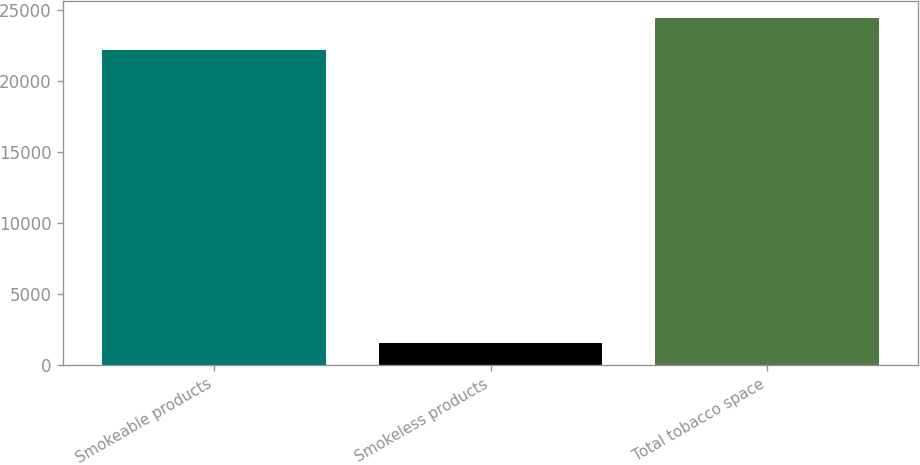Convert chart to OTSL. <chart><loc_0><loc_0><loc_500><loc_500><bar_chart><fcel>Smokeable products<fcel>Smokeless products<fcel>Total tobacco space<nl><fcel>22191<fcel>1552<fcel>24410.1<nl></chart> 